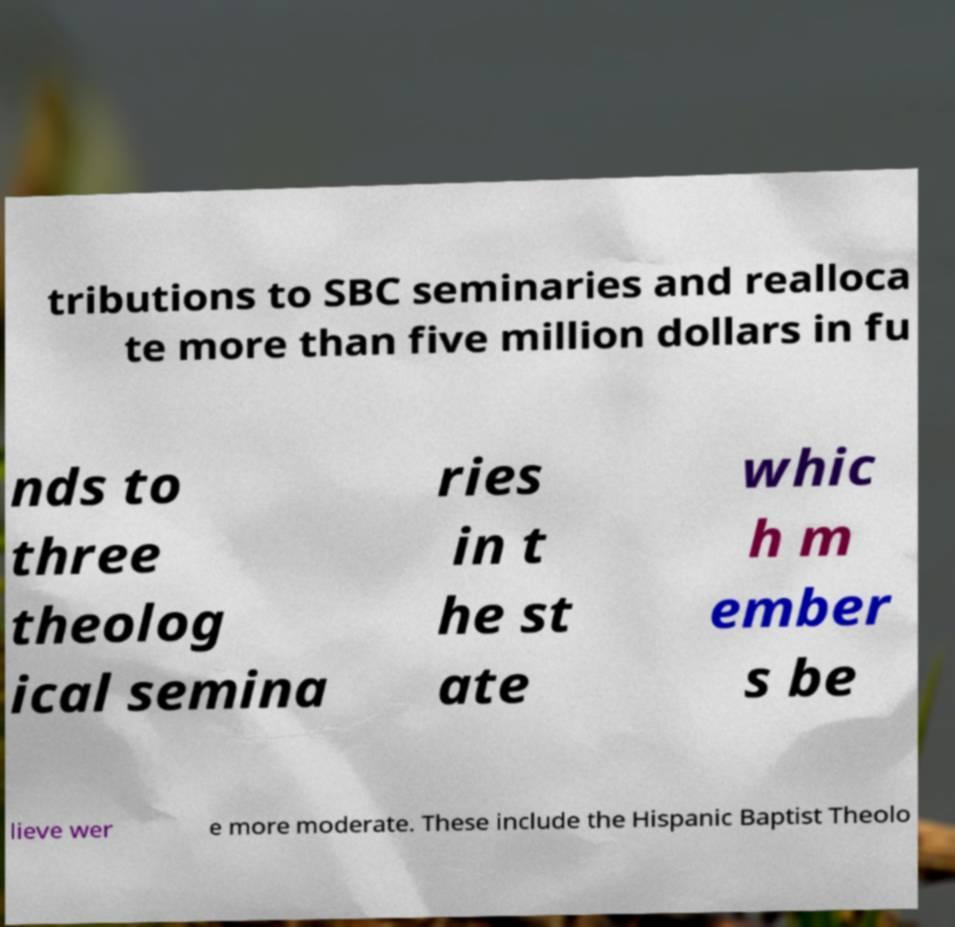There's text embedded in this image that I need extracted. Can you transcribe it verbatim? tributions to SBC seminaries and realloca te more than five million dollars in fu nds to three theolog ical semina ries in t he st ate whic h m ember s be lieve wer e more moderate. These include the Hispanic Baptist Theolo 